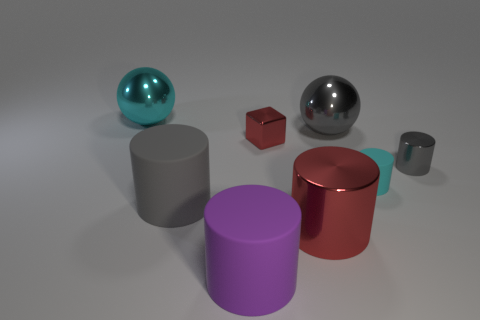Subtract 2 cylinders. How many cylinders are left? 3 Subtract all large purple cylinders. How many cylinders are left? 4 Subtract all red cylinders. How many cylinders are left? 4 Subtract all blue cylinders. Subtract all yellow blocks. How many cylinders are left? 5 Add 1 gray matte objects. How many objects exist? 9 Subtract all cylinders. How many objects are left? 3 Subtract 0 purple cubes. How many objects are left? 8 Subtract all large cylinders. Subtract all big gray matte things. How many objects are left? 4 Add 4 red cylinders. How many red cylinders are left? 5 Add 8 spheres. How many spheres exist? 10 